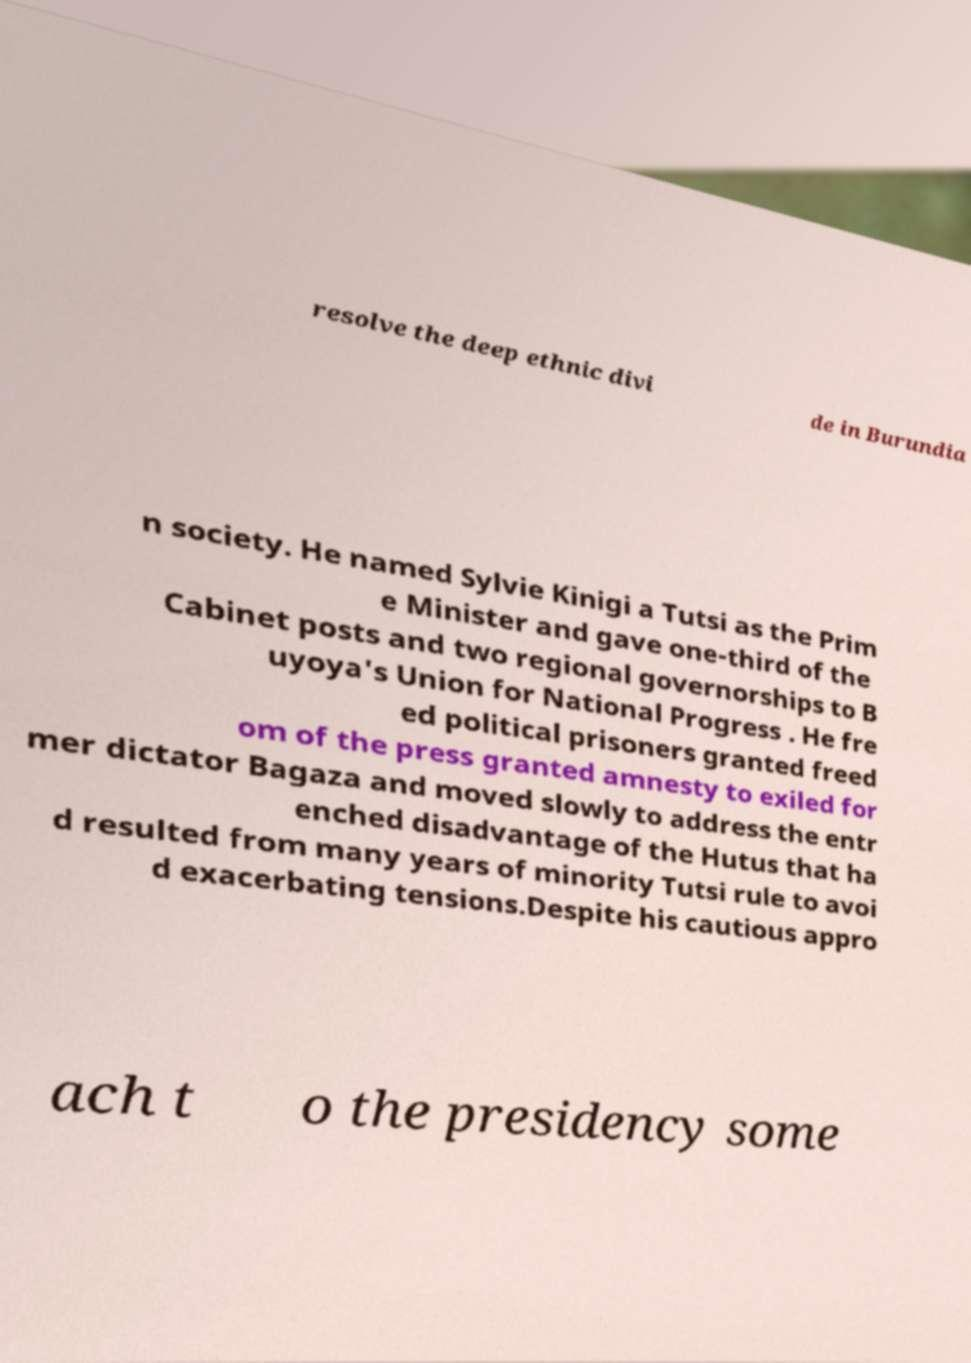For documentation purposes, I need the text within this image transcribed. Could you provide that? resolve the deep ethnic divi de in Burundia n society. He named Sylvie Kinigi a Tutsi as the Prim e Minister and gave one-third of the Cabinet posts and two regional governorships to B uyoya's Union for National Progress . He fre ed political prisoners granted freed om of the press granted amnesty to exiled for mer dictator Bagaza and moved slowly to address the entr enched disadvantage of the Hutus that ha d resulted from many years of minority Tutsi rule to avoi d exacerbating tensions.Despite his cautious appro ach t o the presidency some 